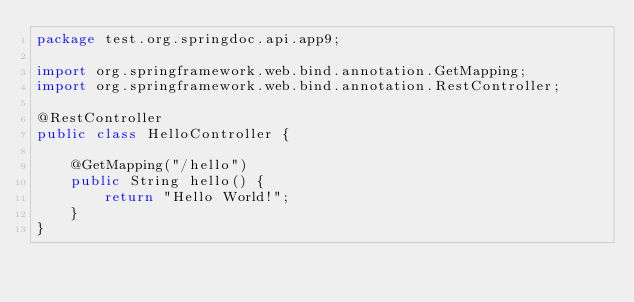<code> <loc_0><loc_0><loc_500><loc_500><_Java_>package test.org.springdoc.api.app9;

import org.springframework.web.bind.annotation.GetMapping;
import org.springframework.web.bind.annotation.RestController;

@RestController
public class HelloController {

    @GetMapping("/hello")
    public String hello() {
        return "Hello World!";
    }
}
</code> 